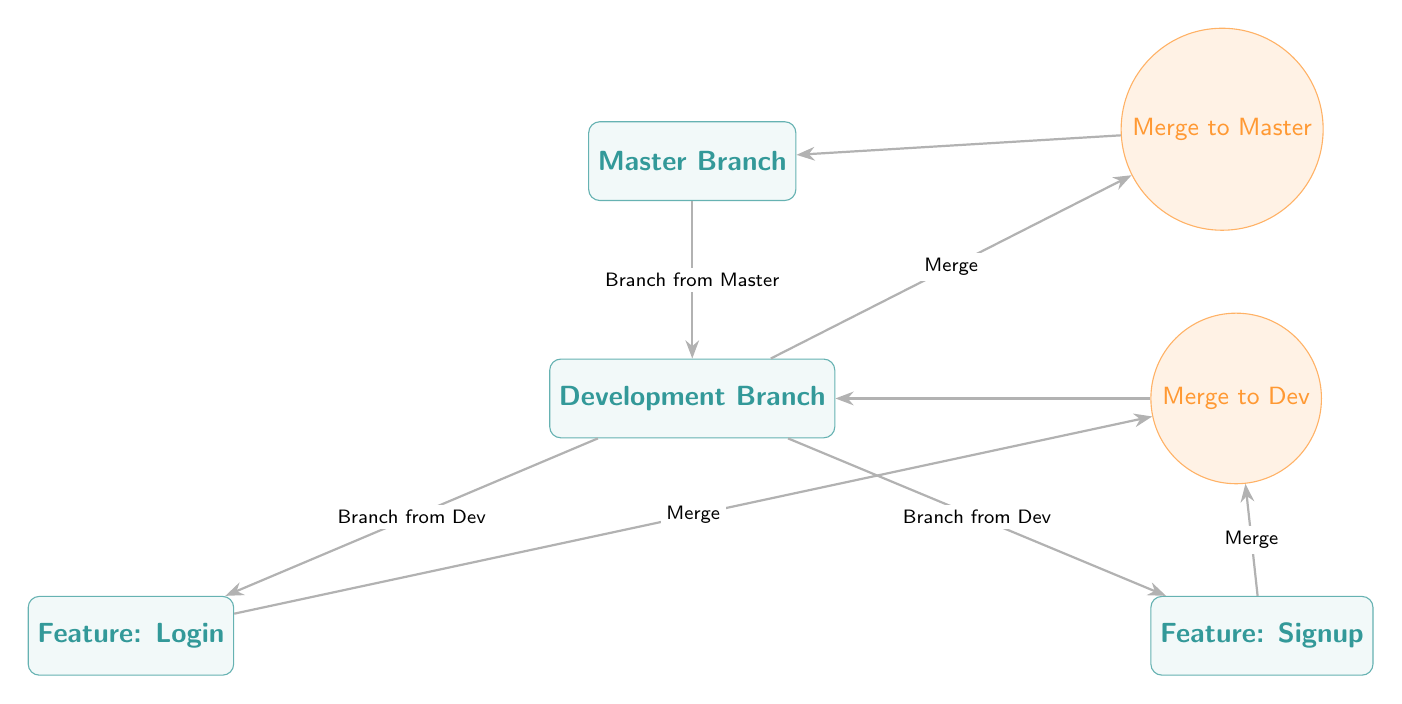What is the highest branch in the diagram? The highest branch is designated as the "Master Branch," which is positioned at the top of the diagram.
Answer: Master Branch How many branches are shown in the diagram? There are a total of four branches illustrated in the diagram: Master Branch, Development Branch, Feature: Login, and Feature: Signup.
Answer: 4 What feature is located to the left of the Development Branch? The feature on the left side of the Development Branch is labeled "Feature: Login."
Answer: Feature: Login Which branch does the Development Branch branch from? The Development Branch branches from the Master Branch, as indicated by the connecting edge labeled "Branch from Master."
Answer: Master Branch What is the final merge destination for the Development Branch? The final merge destination for the Development Branch is the "Master Branch," as shown by the edge connecting from the merge node back to the Master Branch.
Answer: Master Branch Which features are merged into the Development Branch? The features that are merged into the Development Branch are "Feature: Login" and "Feature: Signup," both merging into the Merge to Dev node.
Answer: Feature: Login and Feature: Signup How many merges are there in total shown in the diagram? There are three merges illustrated in the diagram: one from Feature: Login, one from Feature: Signup, and the final merge to Master.
Answer: 3 What type of node is used to represent merges in the diagram? The merges in the diagram are represented by circular nodes, which are styled with the designation "merge."
Answer: Circle What relationship does the edge labeled "Branch from Dev" represent? The edge labeled "Branch from Dev" signifies the branching of the "Feature: Login" from the Development Branch, indicating a new feature development.
Answer: New feature development What color is the Development Branch node? The Development Branch node is colored teal, as indicated by its styling in the diagram.
Answer: Teal 